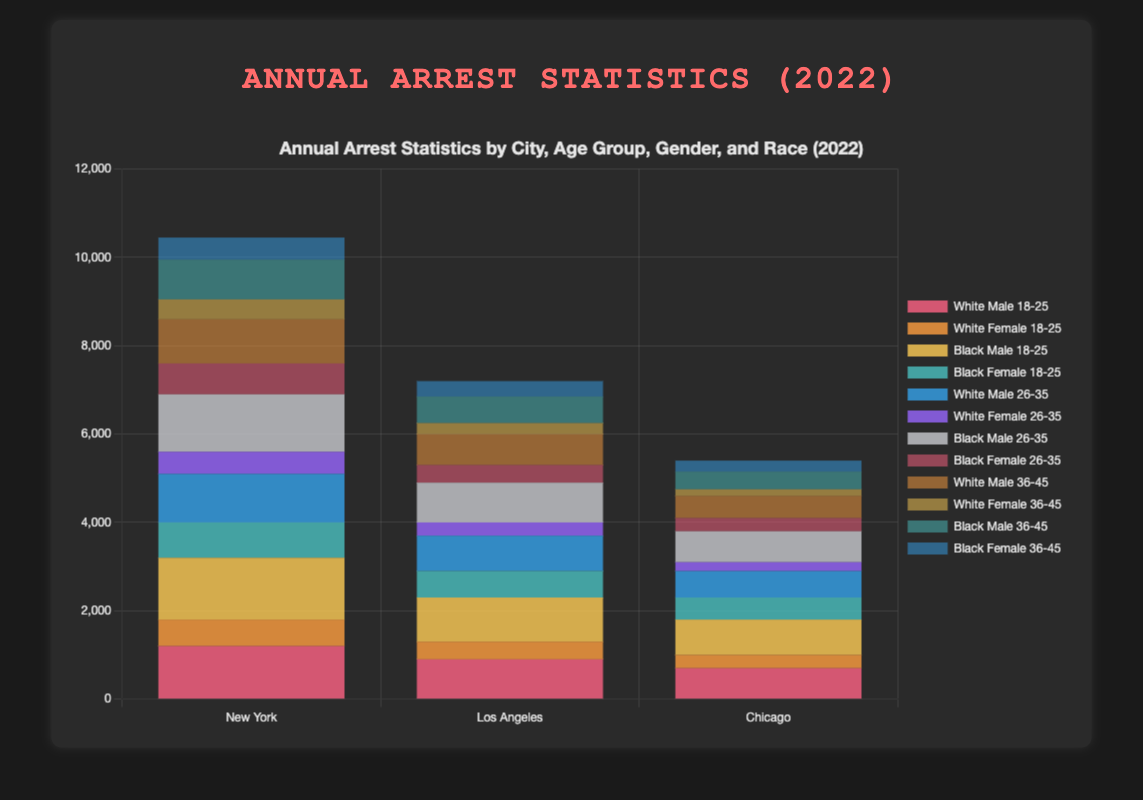Which city has the highest number of arrests for White males aged 18-25? By comparing the heights of the bars representing White males aged 18-25 across all cities, the tallest bar will indicate the city with the highest number of arrests. New York has the tallest bar for this demographic.
Answer: New York Which age group of Black females has the highest total arrests in Los Angeles? Sum the arrest numbers for Black females in each age group in Los Angeles: For 18-25, it's 600; for 26-35, it's 400; and for 36-45, it's 350. The highest total is for the 18-25 age group.
Answer: 18-25 Which city has the least number of arrests for White females aged 36-45? By inspecting the bars representing White females aged 36-45 across all cities, the shortest bar will indicate the city with the lowest number of arrests for this demographic. Chicago has the shortest bar.
Answer: Chicago What is the total number of arrests for Black males in Chicago across all age groups? Sum the arrest numbers for Black males in Chicago in each age group: 800 (18-25) + 700 (26-35) + 400 (36-45). The total is 1900.
Answer: 1900 Compare the number of arrests for Black males aged 18-25 in New York and Los Angeles. Which city has more arrests, and by how much? In New York, the number of arrests for Black males aged 18-25 is 1400. In Los Angeles, it is 1000. The difference is 1400 - 1000 = 400, with New York having more arrests.
Answer: New York by 400 Which gender has more arrests for the age group 26-35 in New York, and what is the difference? In New York, the total arrests for males aged 26-35 are 1100 (White) + 1300 (Black) = 2400. For females, it is 500 (White) + 700 (Black) = 1200. The difference is 2400 - 1200 = 1200, with males having more arrests.
Answer: Males by 1200 Which city has the highest combined arrests for both genders aged 36-45 and of Black race? In New York, the combined arrests are 900 (Male) + 500 (Female) = 1400. In Los Angeles, it's 600 (Male) + 350 (Female) = 950. In Chicago, it's 400 (Male) + 250 (Female) = 650. New York has the highest total.
Answer: New York Compare the visual heights of bars for Black females aged 26-35 across all cities. Which city has the shortest bar, indicating the least arrests? By examining the height of bars for Black females aged 26-35, the shortest bar will indicate the city with the least arrests for this demographic. Chicago has the shortest bar.
Answer: Chicago What is the average number of arrests for White males aged 36-45 across New York, Los Angeles, and Chicago? Sum the arrest numbers: 1000 (New York) + 700 (Los Angeles) + 500 (Chicago) = 2200. Divide by the number of cities, 2200 / 3 = 733.33.
Answer: 733.33 What’s the difference in the total number of arrests for Black females aged 18-25 between New York and Chicago? In New York, the arrests for Black females aged 18-25 is 800. In Chicago, it is 500. The difference is 800 - 500 = 300.
Answer: 300 